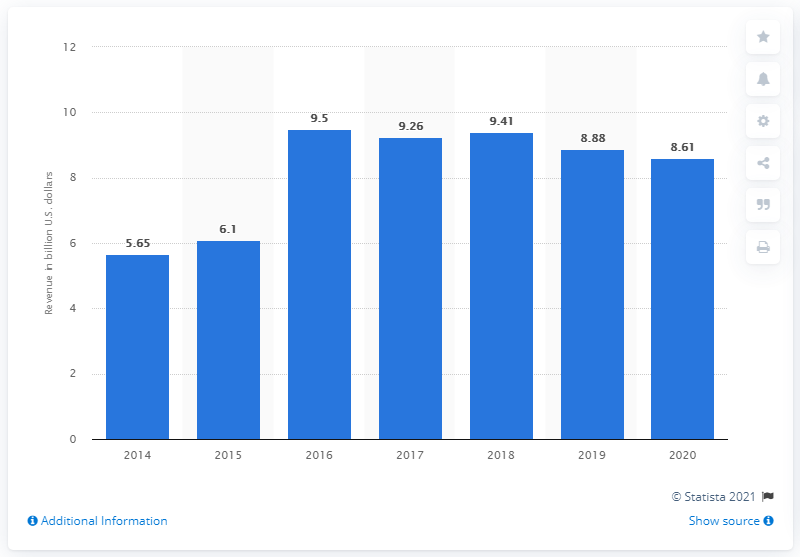Outline some significant characteristics in this image. In 2020, NXP Semiconductors' revenue was 8.61 billion USD. NXP Semiconductors reported revenue of 8.88 billion USD in 2019. NXP Semiconductors' revenue from 2016 to 2018 was approximately 8.61 billion USD. 